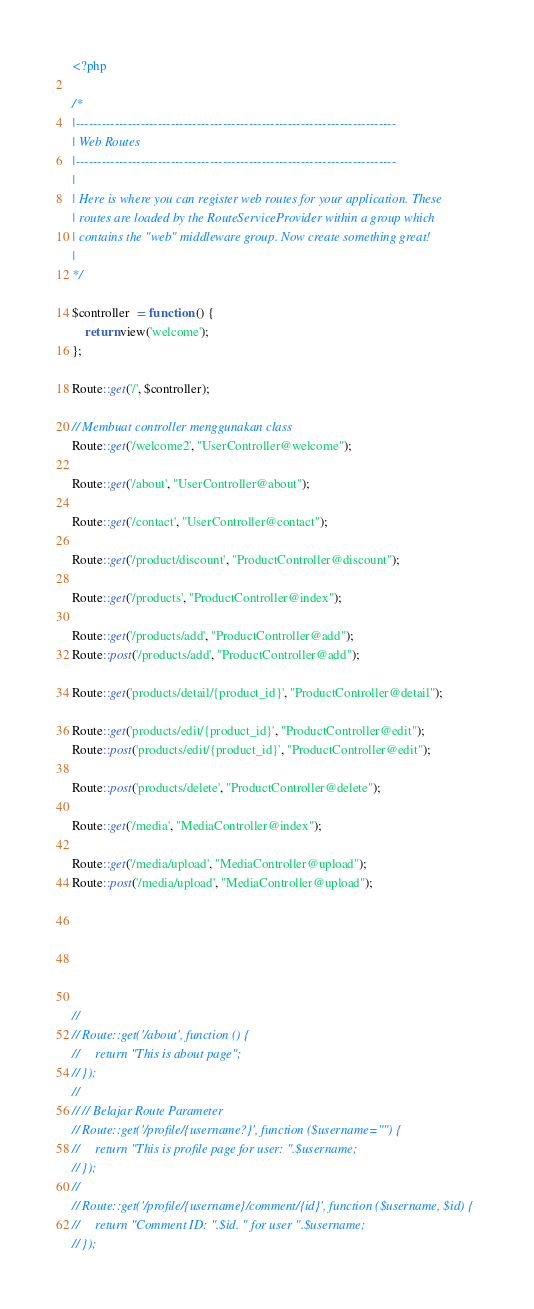Convert code to text. <code><loc_0><loc_0><loc_500><loc_500><_PHP_><?php

/*
|--------------------------------------------------------------------------
| Web Routes
|--------------------------------------------------------------------------
|
| Here is where you can register web routes for your application. These
| routes are loaded by the RouteServiceProvider within a group which
| contains the "web" middleware group. Now create something great!
|
*/

$controller  = function () {
    return view('welcome');
};

Route::get('/', $controller);

// Membuat controller menggunakan class
Route::get('/welcome2', "UserController@welcome");

Route::get('/about', "UserController@about");

Route::get('/contact', "UserController@contact");

Route::get('/product/discount', "ProductController@discount");

Route::get('/products', "ProductController@index");

Route::get('/products/add', "ProductController@add");
Route::post('/products/add', "ProductController@add");

Route::get('products/detail/{product_id}', "ProductController@detail");

Route::get('products/edit/{product_id}', "ProductController@edit");
Route::post('products/edit/{product_id}', "ProductController@edit");

Route::post('products/delete', "ProductController@delete");

Route::get('/media', "MediaController@index");

Route::get('/media/upload', "MediaController@upload");
Route::post('/media/upload', "MediaController@upload");






//
// Route::get('/about', function () {
//     return "This is about page";
// });
//
// // Belajar Route Parameter
// Route::get('/profile/{username?}', function ($username="") {
//     return "This is profile page for user: ".$username;
// });
//
// Route::get('/profile/{username}/comment/{id}', function ($username, $id) {
//     return "Comment ID: ".$id. " for user ".$username;
// });
</code> 